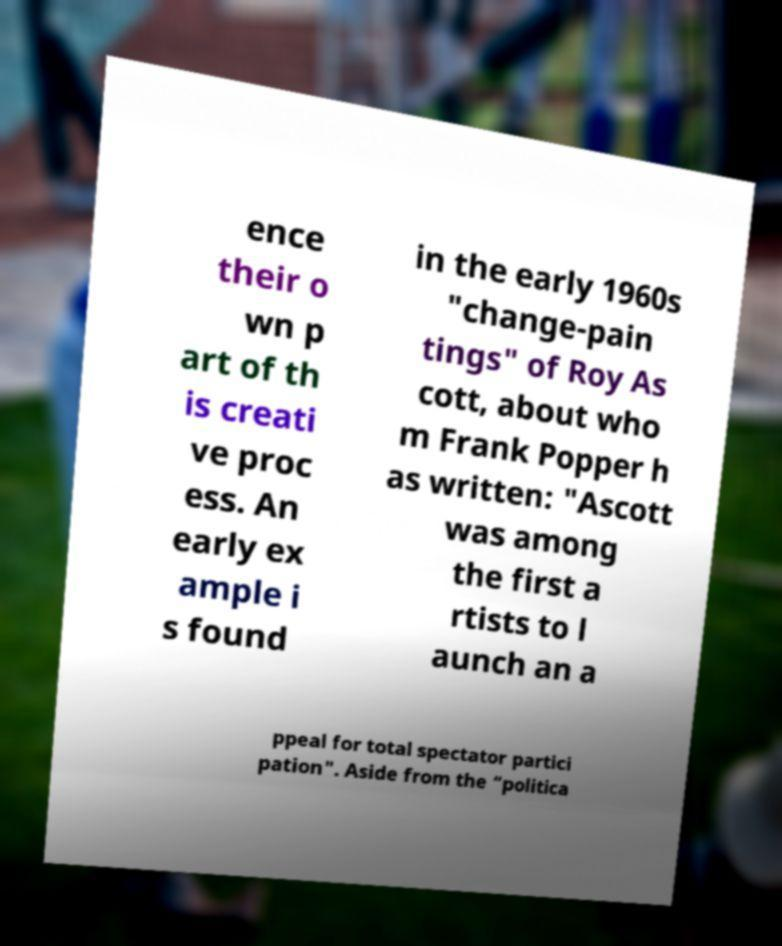I need the written content from this picture converted into text. Can you do that? ence their o wn p art of th is creati ve proc ess. An early ex ample i s found in the early 1960s "change-pain tings" of Roy As cott, about who m Frank Popper h as written: "Ascott was among the first a rtists to l aunch an a ppeal for total spectator partici pation". Aside from the “politica 